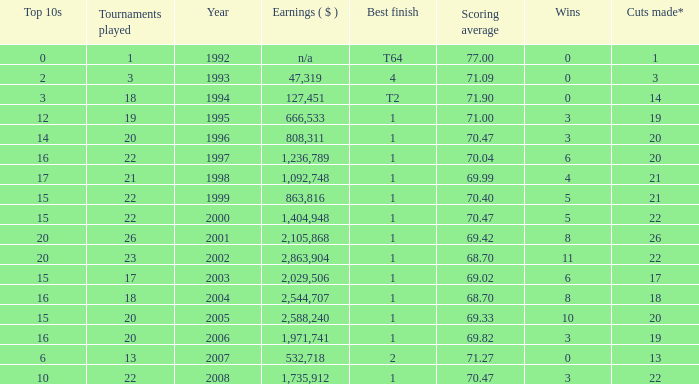Provide the scoring mean for years preceding 1998 with over 3 successes. 70.04. 